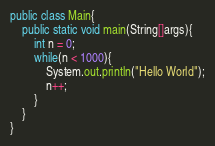Convert code to text. <code><loc_0><loc_0><loc_500><loc_500><_Java_>public class Main{
	public static void main(String[]args){
		int n = 0;
		while(n < 1000){
			System.out.println("Hello World");
			n++;
		}
	}
}</code> 